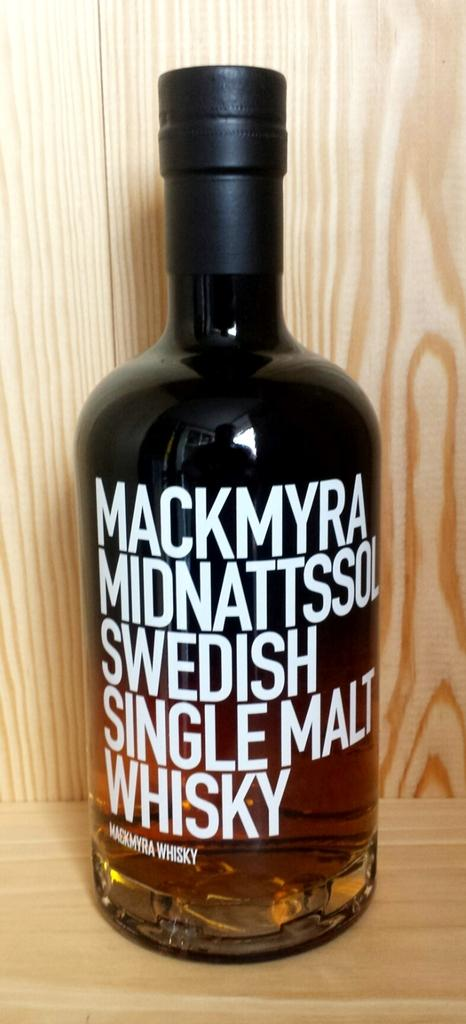Provide a one-sentence caption for the provided image. A large, brown bottle of Swedish Single Malt Whiskey. 